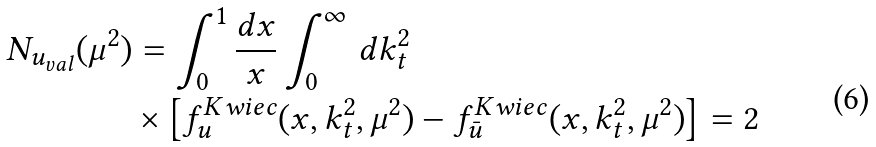<formula> <loc_0><loc_0><loc_500><loc_500>N _ { u _ { v a l } } ( \mu ^ { 2 } ) & = \int _ { 0 } ^ { 1 } \frac { d x } { x } \int _ { 0 } ^ { \infty } \, d k _ { t } ^ { 2 } \\ & \times \left [ f _ { u } ^ { K w i e c } ( x , k _ { t } ^ { 2 } , \mu ^ { 2 } ) - f _ { \bar { u } } ^ { K w i e c } ( x , k _ { t } ^ { 2 } , \mu ^ { 2 } ) \right ] = 2 \\ \,</formula> 